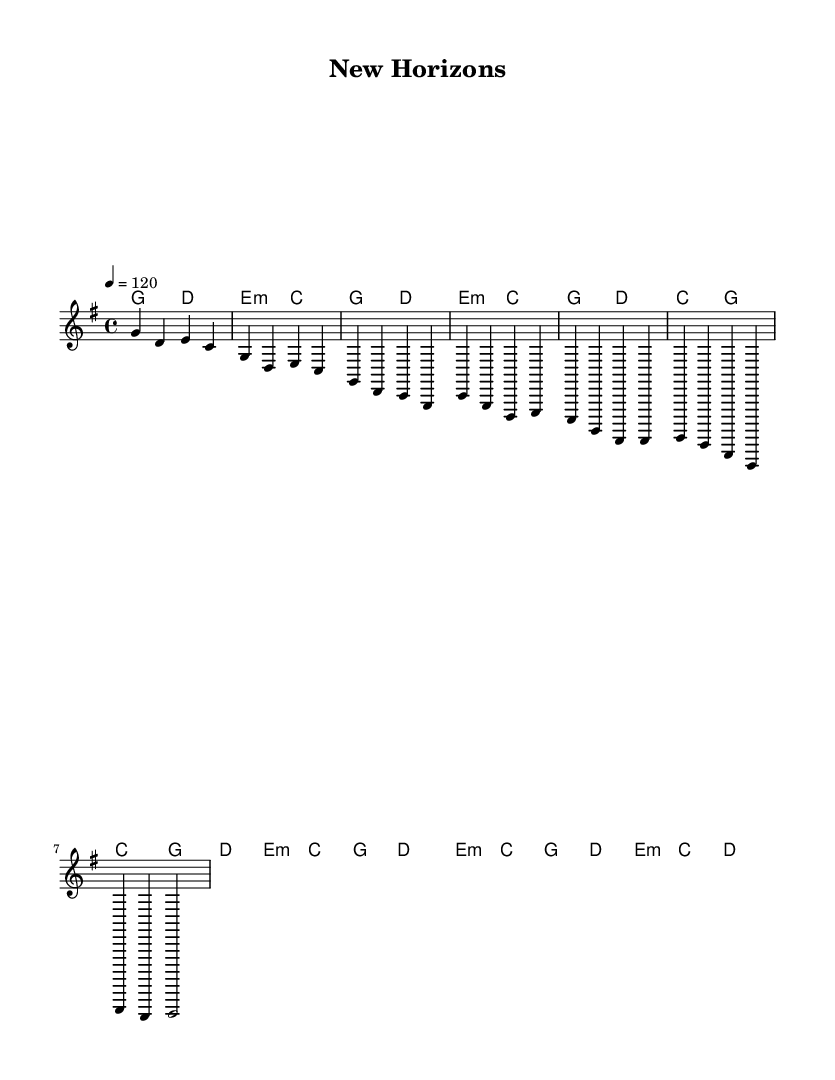What is the key signature of this music? The key signature is G major, which has one sharp (F#). This can be determined by looking at the key signature in the top left of the sheet music.
Answer: G major What is the time signature of this music? The time signature is 4/4, which means there are four beats in each measure and the quarter note gets one beat. This can be found at the beginning of the sheet music next to the key signature.
Answer: 4/4 What is the tempo marking for this piece? The tempo marking indicates a speed of quarter note = 120 beats per minute. This can be identified where it specifies the tempo with "4 = 120".
Answer: 120 How many measures are included in the chorus section? The chorus section consists of two measures, as indicated by the use of the notes and corresponding bar lines. It can be found in the segment labeled "Chorus (partial)".
Answer: 2 What is the chord progression for the first measure? The first measure is composed of the G major chord, which is noted in the harmonies line. This corresponds directly to the melody's note played at the same time.
Answer: G major What is the overall structure of the song based on the sections present? The structure of the song follows a common pop format, which includes an intro, verses, a chorus, and a bridge. This can be determined by analyzing the labeled sections of the sheet music.
Answer: Intro, Verse, Chorus, Bridge Which chord has a minor quality in the progression? The E minor chord is noted within the harmony section, indicated by the "m" notation after the E. It is identifiable in the sections provided in the sheet music.
Answer: E minor 